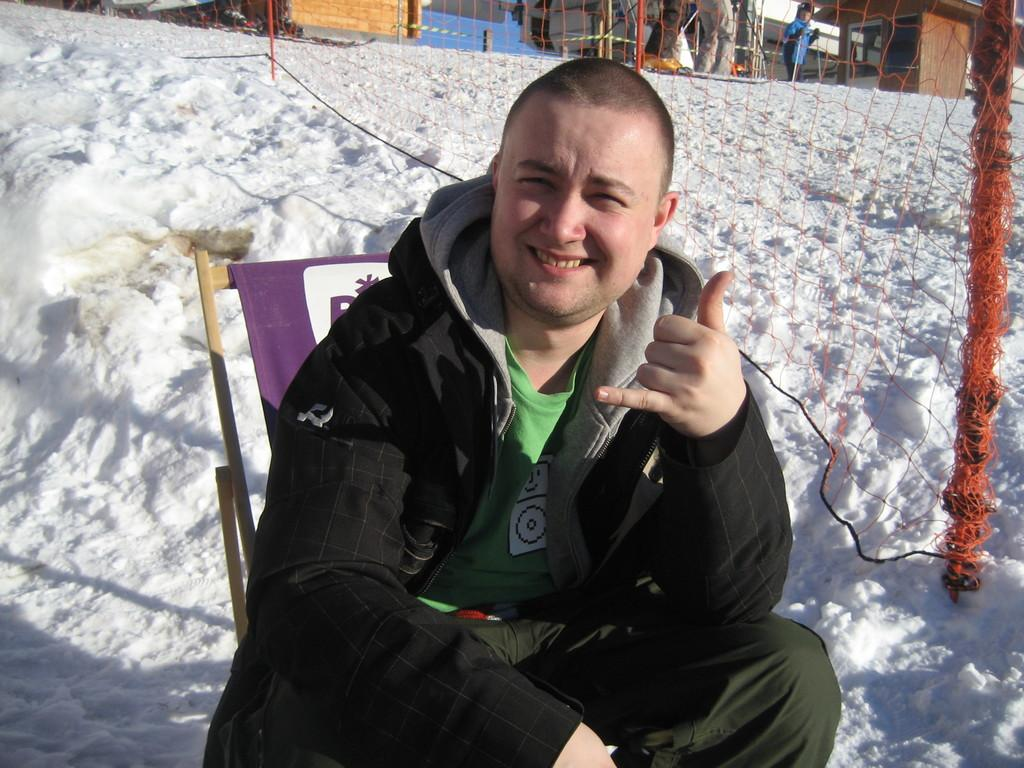What is the main subject of the image? There is a man in the image. What is the man doing in the image? The man is sitting on a chair and posing for a photo. What is the man wearing in the image? The man is wearing a black jacket. What can be seen behind the man in the image? There is a net behind the man. What is the overall setting of the image? The entire area in the image is covered with snow. What type of brass instrument is the man playing in the image? There is no brass instrument present in the image; the man is posing for a photo while sitting on a chair. 